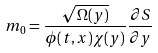<formula> <loc_0><loc_0><loc_500><loc_500>m _ { 0 } = \frac { \sqrt { \Omega ( y ) } } { \phi ( t , x ) \chi ( y ) } \frac { \partial S } { \partial y }</formula> 